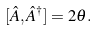Convert formula to latex. <formula><loc_0><loc_0><loc_500><loc_500>[ \hat { A } , \hat { A } ^ { \dagger } ] = 2 \theta .</formula> 